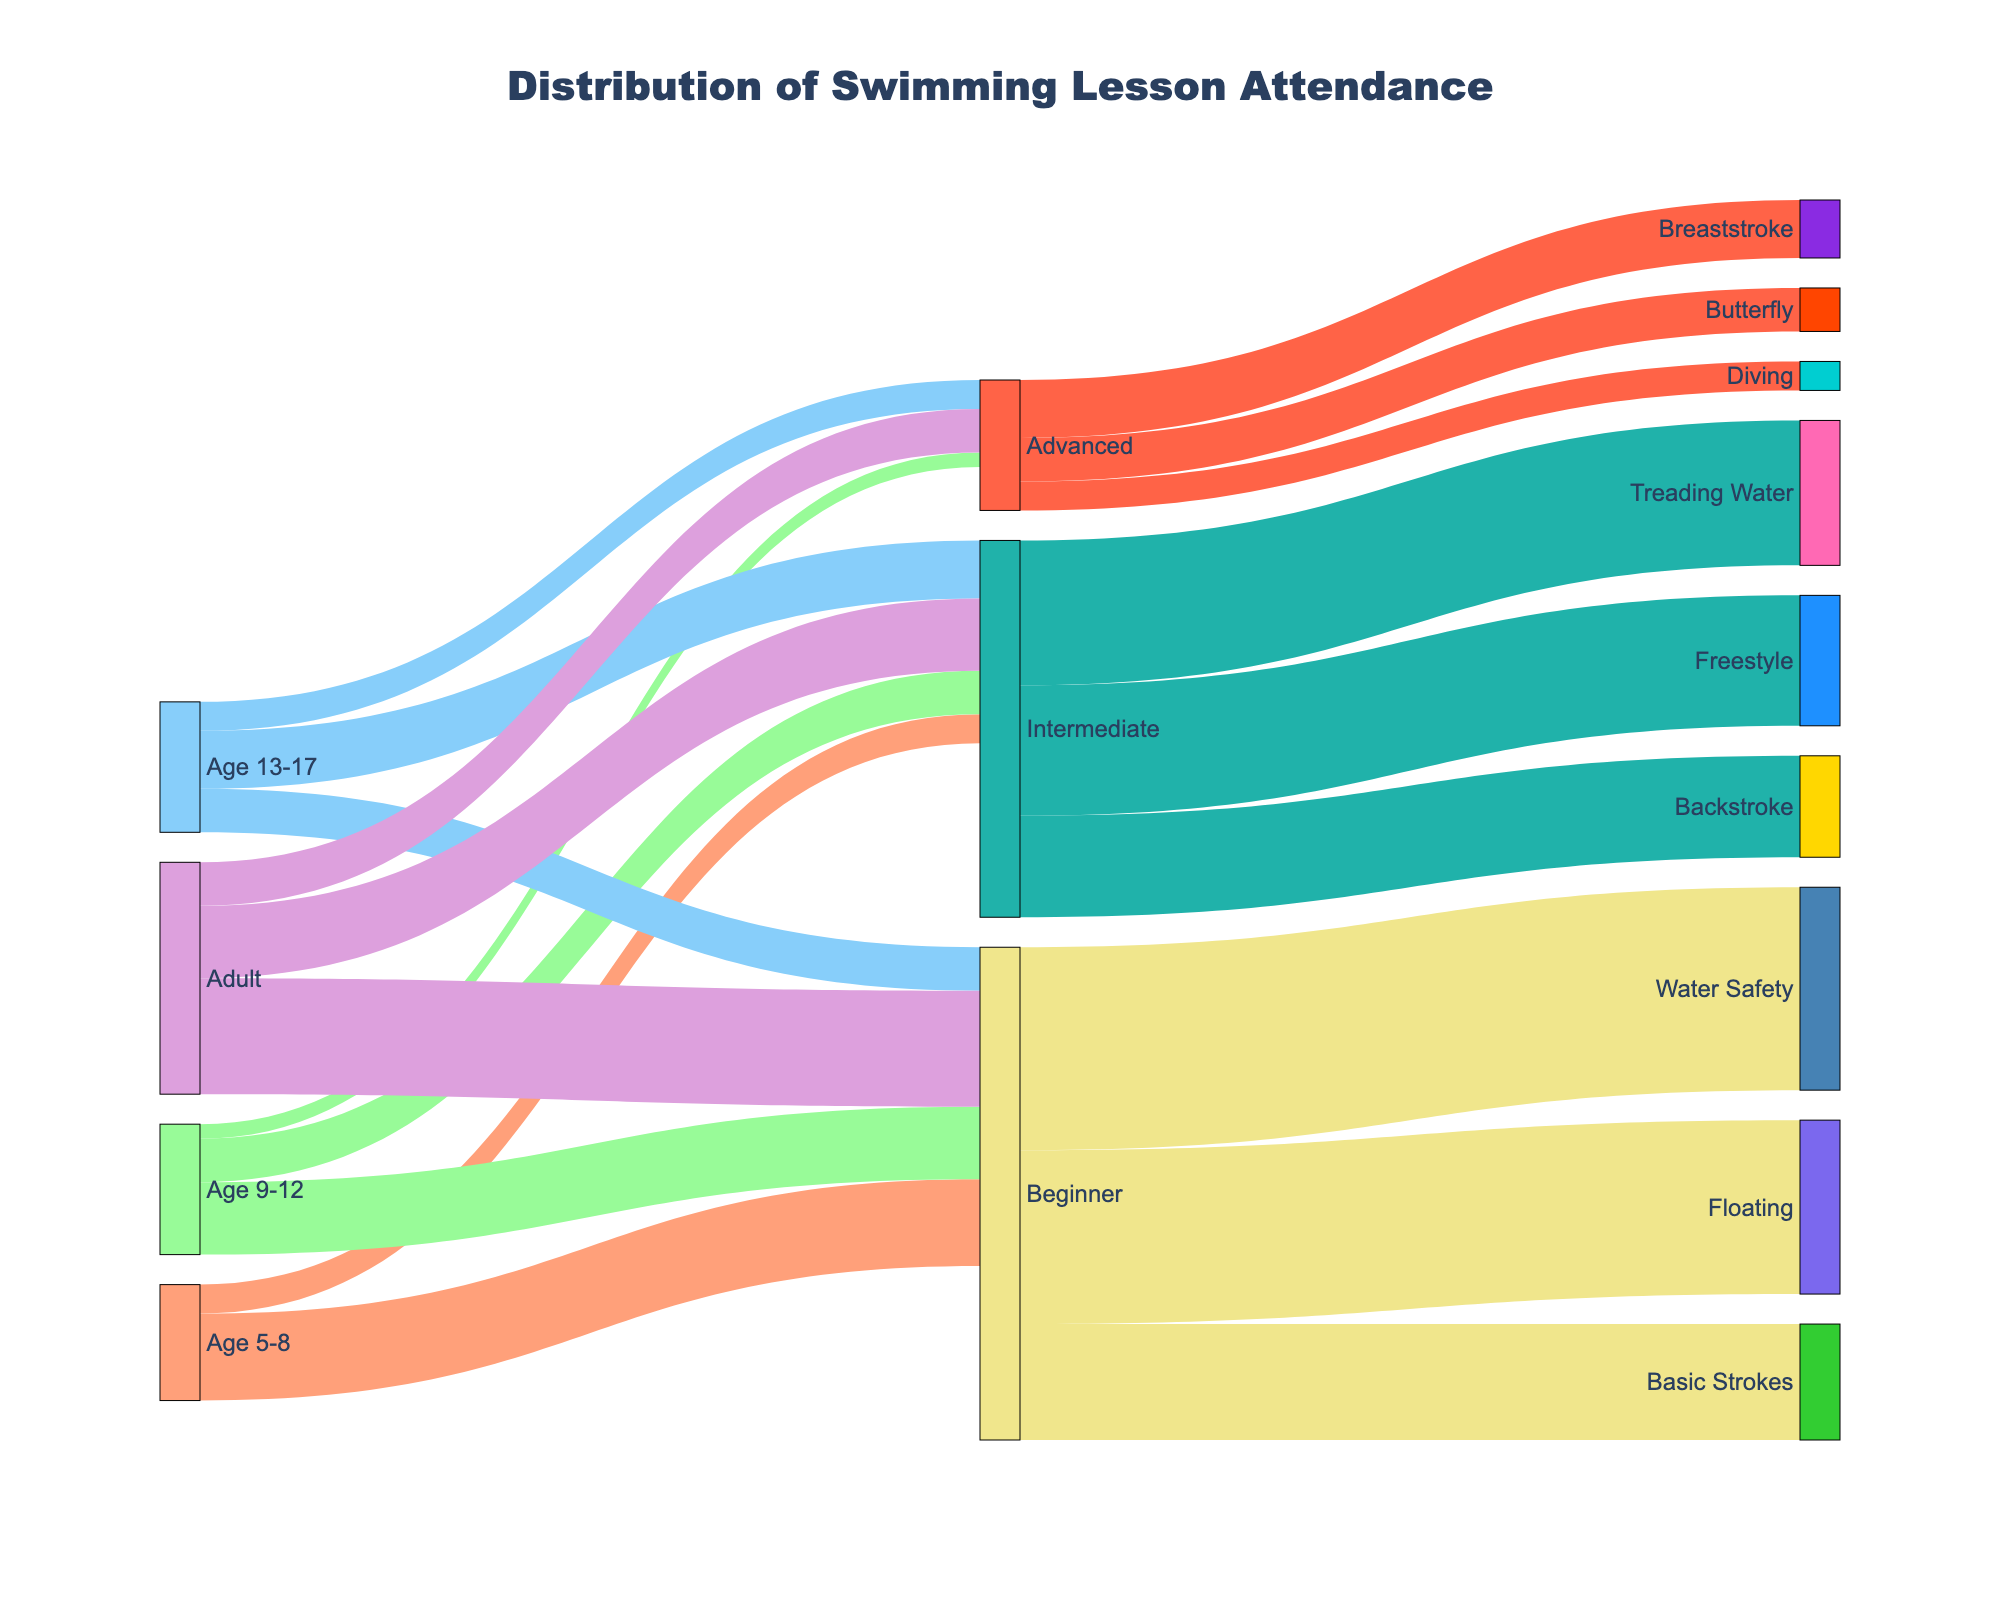What's the title of the figure? The title is usually prominently displayed at the top of the figure. In this case, it's "Distribution of Swimming Lesson Attendance" based on the code given.
Answer: Distribution of Swimming Lesson Attendance Which age group has the highest total attendance? To determine this, sum the values of all skill levels for each age group. Age 5-8 has 30 + 10 = 40, Age 9-12 has 25 + 15 + 5 = 45, Age 13-17 has 15 + 20 + 10 = 45, and Adults have 40 + 25 + 15 = 80. The highest total attendance is for Adults.
Answer: Adults Which skill level has the highest number of participants from the Adult age group? To find this, look at the values for each skill level within the Adult age group. The numbers are 40 for Beginner, 25 for Intermediate, and 15 for Advanced. Beginner level has the highest number of participants.
Answer: Beginner How many more Beginner students are there than Intermediate students in the Adult age group? Subtract the number of Intermediate students from the number of Beginner students in the Adult age group. There are 40 Beginner students and 25 Intermediate students. 40 - 25 = 15.
Answer: 15 What proportion of the Beginner level students focus on Water Safety? First, find the total number of Beginner level students. Sum the values for Water Safety, Floating, and Basic Strokes: 70 + 60 + 40 = 170. The number focusing on Water Safety is 70. Proportion is 70/170.
Answer: 70/170 Which skill level has the highest number of students learning Freestyle? To determine this, look at the connection between skill levels and Freestyle. The value is 45, which corresponds to the Intermediate skill level.
Answer: Intermediate What’s the total number of students learning Advanced skills? Sum the values for Breaststroke, Butterfly, and Diving under the Advanced skill category: 20 + 15 + 10 = 45.
Answer: 45 Compare the number of Intermediate students focusing on Freestyle vs. Backstroke. The values for Freestyle and Backstroke under Intermediate skill level are 45 and 35, respectively. Freestyle has more students.
Answer: Freestyle has more students Which age group has an equal number of Beginner and Intermediate students? Look for an age group where the values for Beginner and Intermediate students are the same. None of the age groups have an equal number of Beginner and Intermediate students; they all differ.
Answer: None 